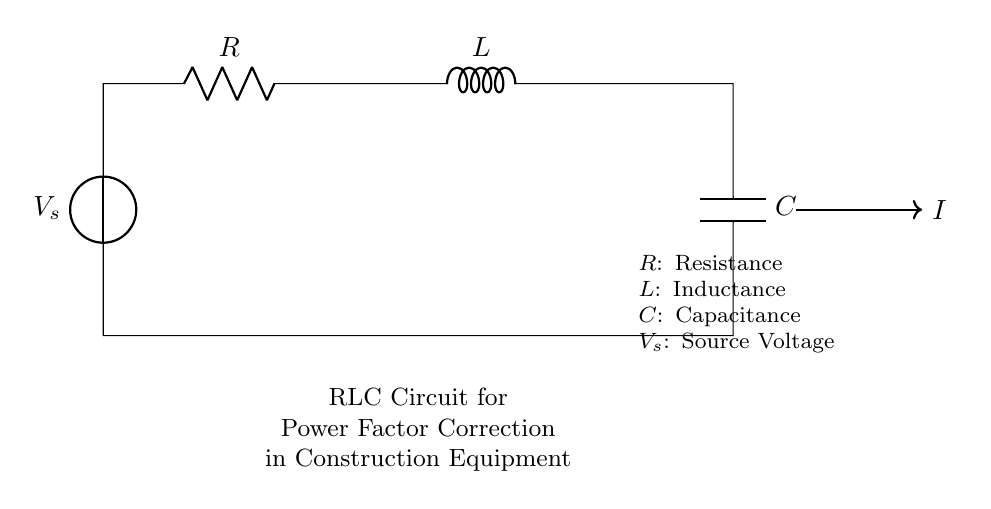What are the components of this circuit? The circuit contains a resistor, inductor, and capacitor, which are clearly labeled as R, L, and C respectively.
Answer: Resistor, Inductor, Capacitor What is the source voltage in this RLC circuit? The source voltage is denoted as V_s in the circuit, which is the voltage supply entering the circuit.
Answer: V_s What role does the capacitor play in this circuit? The capacitor is used for power factor correction, which is essential in improving the efficiency of the circuit in construction equipment.
Answer: Power factor correction What is the connection type between the components? The components are connected in a series configuration, as indicated by the direct line connections from the voltage source through R, L, and C.
Answer: Series What happens to the current as it flows through the RLC circuit? As the current passes through R, it experiences resistive loss, inductively stores energy in L, and charge in C, affecting phase or power factor.
Answer: Current changes phase What is the significance of power factor correction in construction equipment? Power factor correction improves the efficiency and reduces the reactive power, which is beneficial for heavy machinery that often operates with inductive loads.
Answer: Efficiency improvement How does the inductor impact the circuit? The inductor opposes changes in current, creating a phase shift that can result in lower power factors if not corrected by the capacitor.
Answer: Creates phase shift 